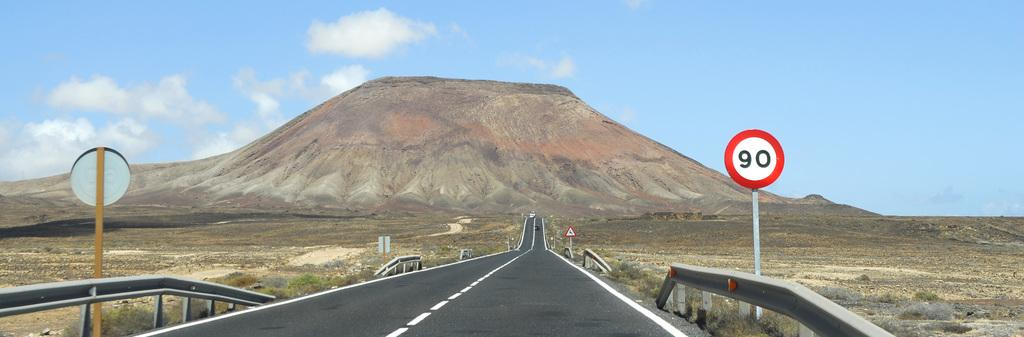<image>
Offer a succinct explanation of the picture presented. a long highway with a sign that has the number 90 on it 